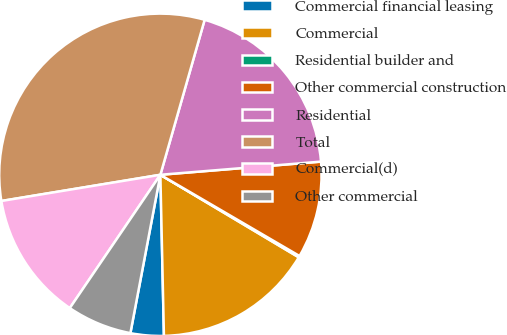Convert chart to OTSL. <chart><loc_0><loc_0><loc_500><loc_500><pie_chart><fcel>Commercial financial leasing<fcel>Commercial<fcel>Residential builder and<fcel>Other commercial construction<fcel>Residential<fcel>Total<fcel>Commercial(d)<fcel>Other commercial<nl><fcel>3.33%<fcel>16.09%<fcel>0.15%<fcel>9.71%<fcel>19.27%<fcel>32.03%<fcel>12.9%<fcel>6.52%<nl></chart> 